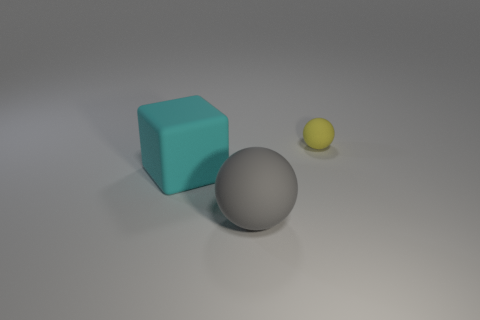There is a sphere that is the same size as the rubber block; what is its material?
Ensure brevity in your answer.  Rubber. How many yellow spheres are made of the same material as the large cyan block?
Your answer should be very brief. 1. What color is the big object that is made of the same material as the gray ball?
Ensure brevity in your answer.  Cyan. There is a thing that is on the left side of the big thing to the right of the big thing that is behind the gray rubber ball; how big is it?
Give a very brief answer. Large. Is the number of big spheres less than the number of tiny blue shiny cylinders?
Give a very brief answer. No. What is the color of the other small matte object that is the same shape as the gray matte object?
Provide a succinct answer. Yellow. There is a matte object that is right of the thing that is in front of the big cube; is there a small object that is behind it?
Keep it short and to the point. No. Is the yellow rubber object the same shape as the gray matte object?
Provide a succinct answer. Yes. Is the number of yellow rubber objects to the left of the large gray object less than the number of big gray objects?
Provide a succinct answer. Yes. The big object that is behind the ball on the left side of the thing that is behind the cyan rubber object is what color?
Keep it short and to the point. Cyan. 